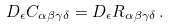<formula> <loc_0><loc_0><loc_500><loc_500>D _ { \epsilon } C _ { \alpha \beta \gamma \delta } = D _ { \epsilon } R _ { \alpha \beta \gamma \delta } \, .</formula> 